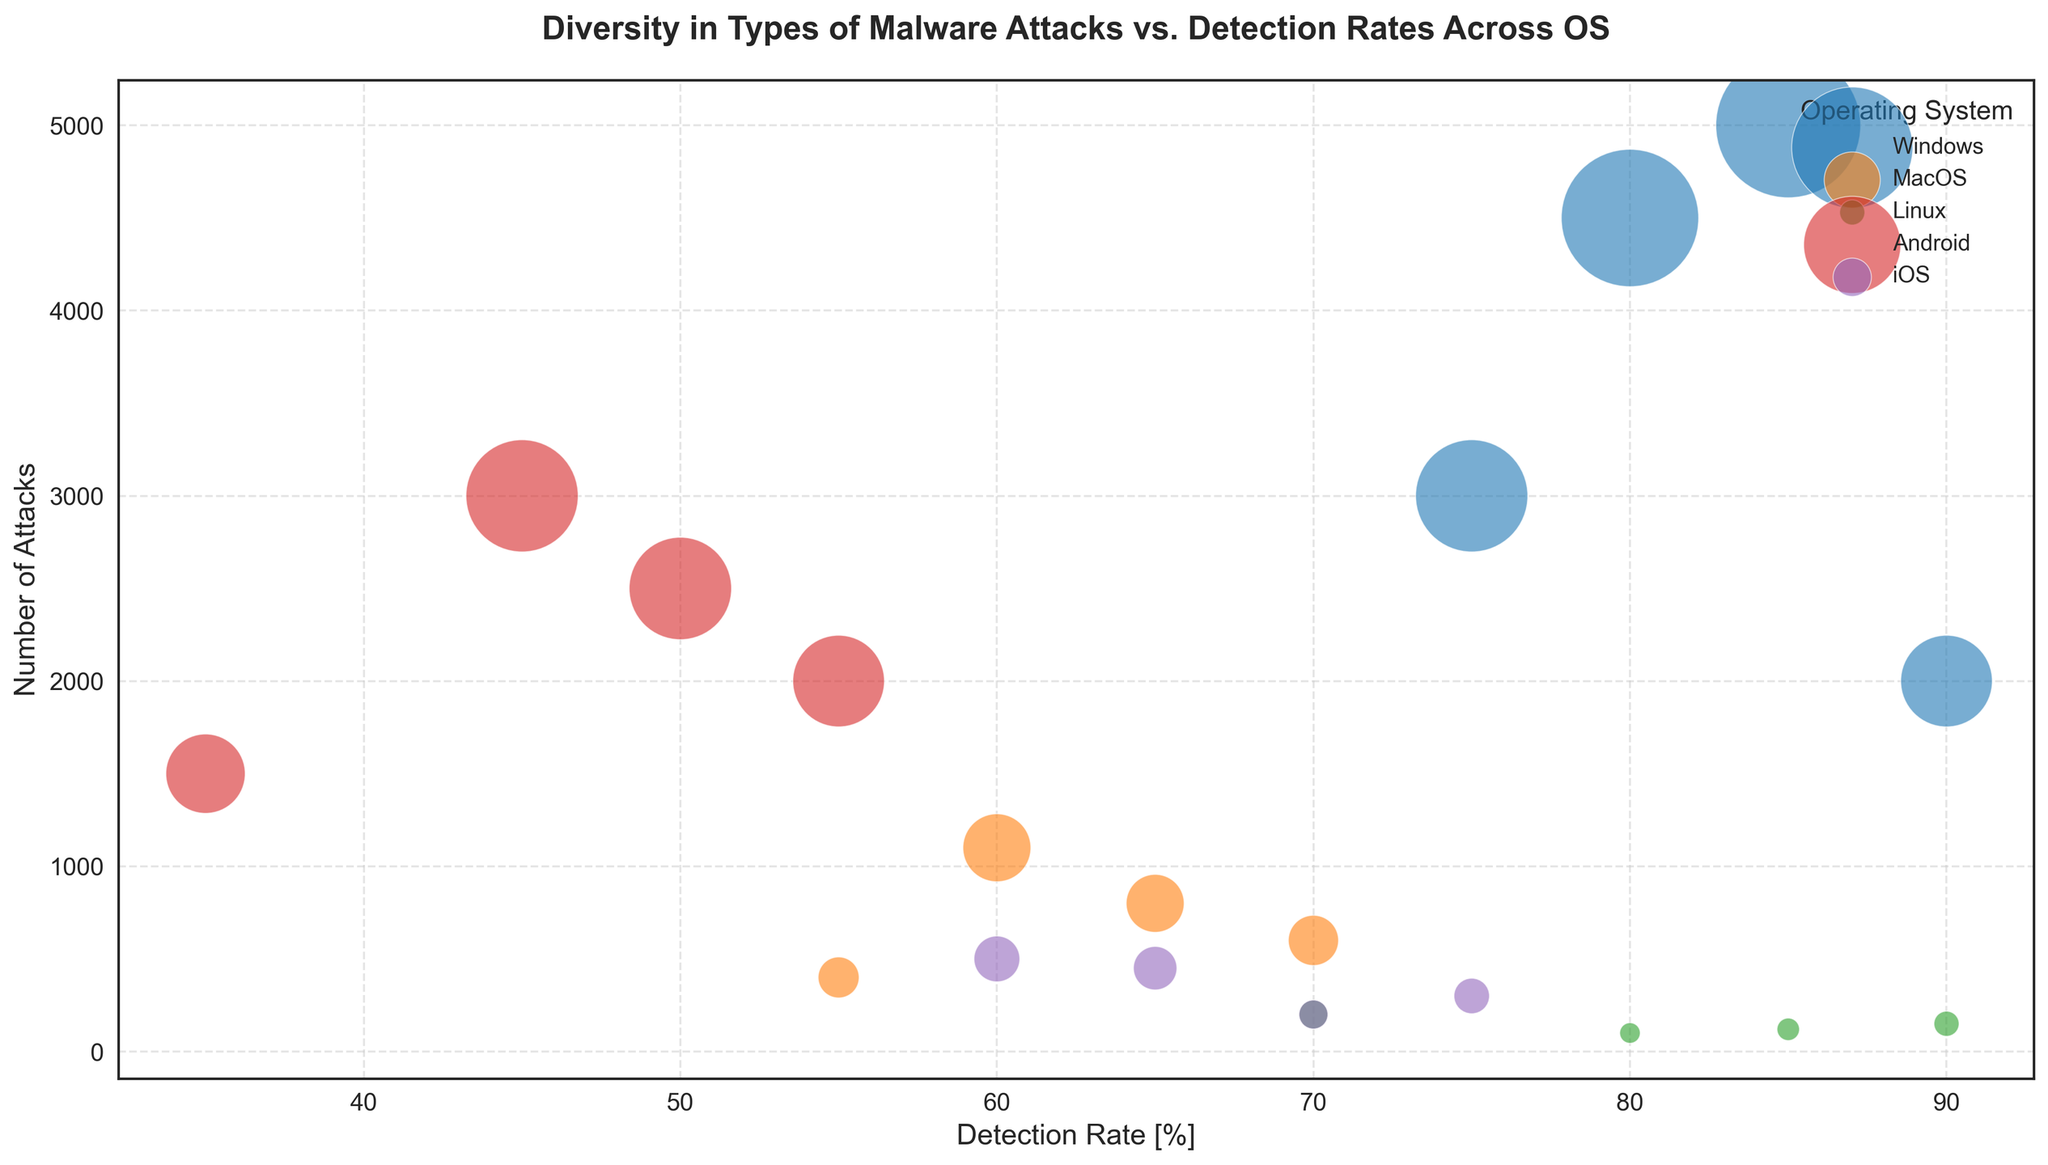What's the detection rate of ransomware attacks on Windows compared to that of MacOS? The figure shows the detection rate of ransomware attacks for Windows as 85% and for MacOS as 65%. By comparing these two values, we find that the detection rate is higher for Windows.
Answer: Windows has a higher detection rate Which operating system has the highest number of attacks for trojan malware? Looking at the bubble sizes for trojan malware across different operating systems, the largest bubble is for Android, indicating it has the highest number of trojan attacks.
Answer: Android Is the detection rate for spyware higher on Linux or MacOS? The figure shows the detection rate of spyware for Linux as 85% and for MacOS as 55%. By comparing these two values, we see that the detection rate is higher on Linux.
Answer: Linux What is the average detection rate of adware across all operating systems? We need to sum the detection rates of adware for all operating systems and then divide by the number of operating systems. The rates are 90% (Windows), 70% (MacOS), 80% (Linux), 55% (Android), and 75% (iOS). So, (90 + 70 + 80 + 55 + 75) / 5 = 370 / 5.
Answer: 74% Which type of malware has the least number of attacks on iOS? By comparing the bubble sizes for the different types of malware on iOS, we see that the smallest bubble corresponds to spyware, indicating the least number of attacks.
Answer: Spyware What is the total number of attacks on Linux across all types of malware? Summing the number of attacks for all types of malware on Linux: 200 (ransomware) + 150 (trojan) + 100 (adware) + 120 (spyware) = 570.
Answer: 570 Do Windows or Android have a higher detection rate for adware? Comparing the detection rates for adware, we see that Windows has a rate of 90% while Android has a rate of 55%. Thus, Windows has a higher detection rate.
Answer: Windows How does the detection rate for trojans on Android compare to that on iOS? The detection rate for trojans on Android is 45%, while on iOS it is 65%. This shows that the detection rate on iOS is higher.
Answer: iOS has a higher detection rate Which operating system shows the highest detection rate for trojan malware? By looking at the detection rates for trojan malware across the operating systems, we see that Linux has the highest rate at 90%.
Answer: Linux Is the number of ransomware attacks on Windows greater than the sum of ransomware attacks on MacOS and Android? The number of ransomware attacks on Windows is 5000. The sum of ransomware attacks on MacOS and Android is 800 + 2500 = 3300. Since 5000 is greater than 3300, Windows has more ransomware attacks.
Answer: Yes 